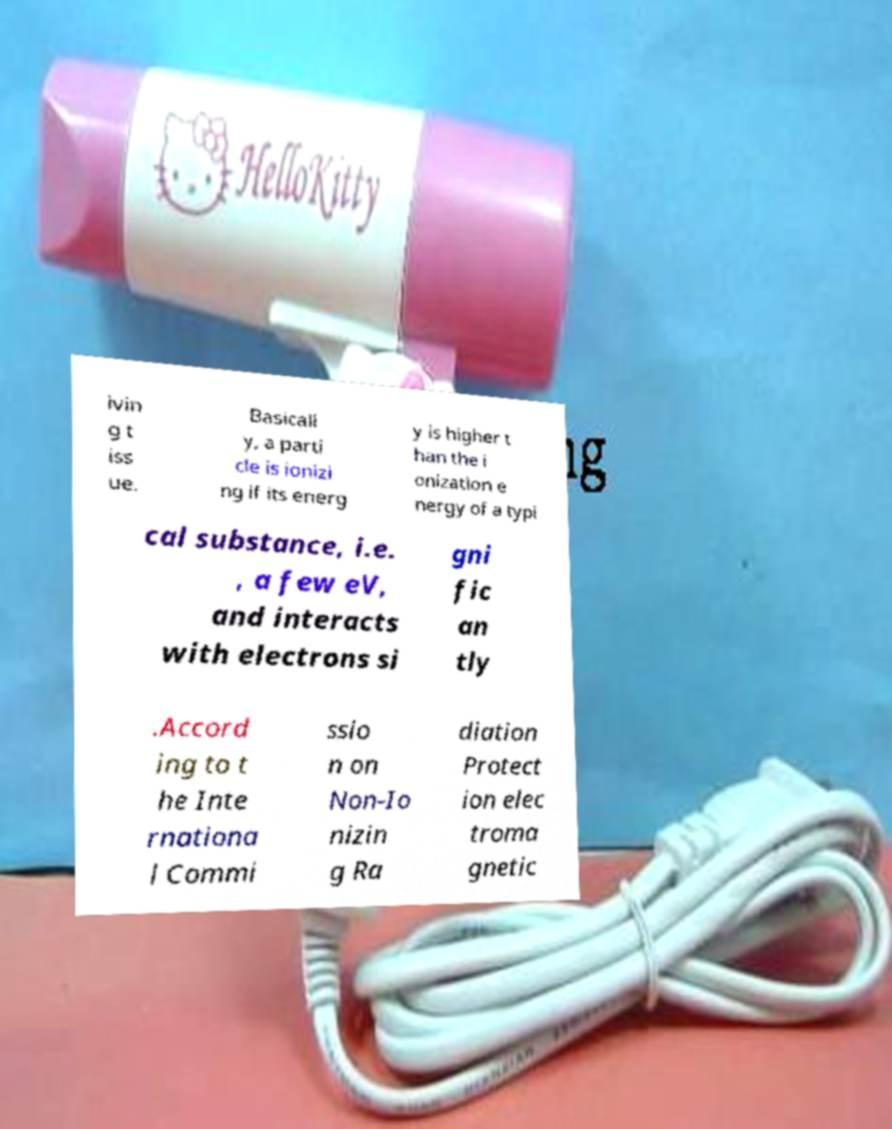Could you assist in decoding the text presented in this image and type it out clearly? ivin g t iss ue. Basicall y, a parti cle is ionizi ng if its energ y is higher t han the i onization e nergy of a typi cal substance, i.e. , a few eV, and interacts with electrons si gni fic an tly .Accord ing to t he Inte rnationa l Commi ssio n on Non-Io nizin g Ra diation Protect ion elec troma gnetic 